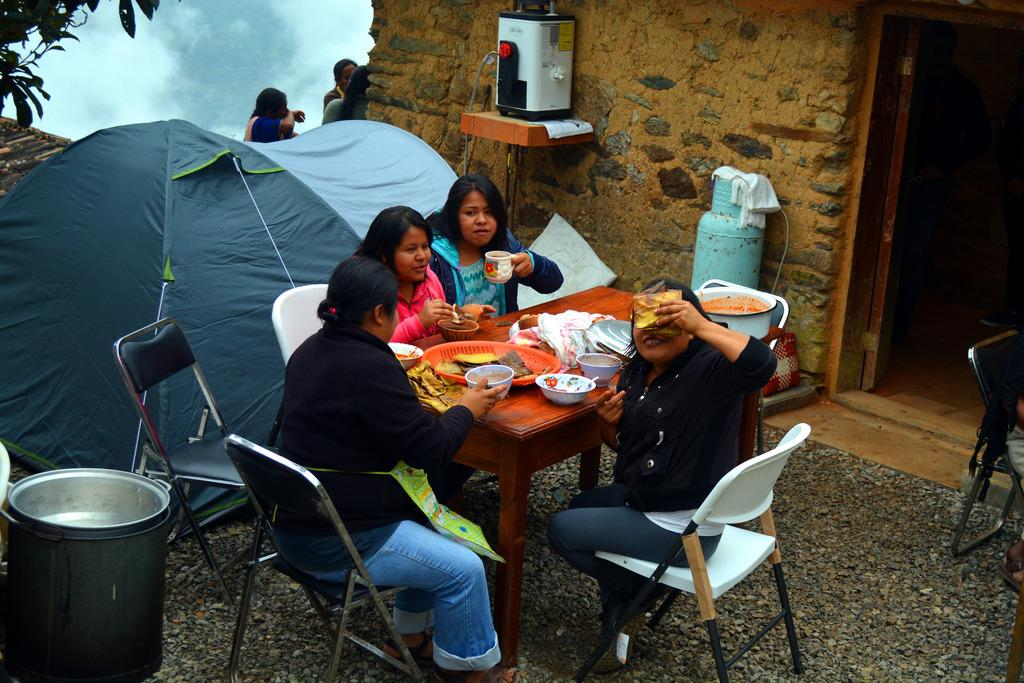What are the people in the image doing? The people in the image are sitting on chairs. What is on the table in the image? There is a bowl, food, spoons, and a cloth on the table in the image. Can you describe the setting of the image? There is a house visible in the background of the image. What note is the daughter playing on the piano in the image? There is no daughter or piano present in the image. Where is the sink located in the image? There is no sink visible in the image. 